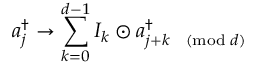<formula> <loc_0><loc_0><loc_500><loc_500>a _ { j } ^ { \dag } \rightarrow \sum _ { k = 0 } ^ { d - 1 } I _ { k } \odot a _ { { j + k } \pmod { d } } ^ { \dag }</formula> 